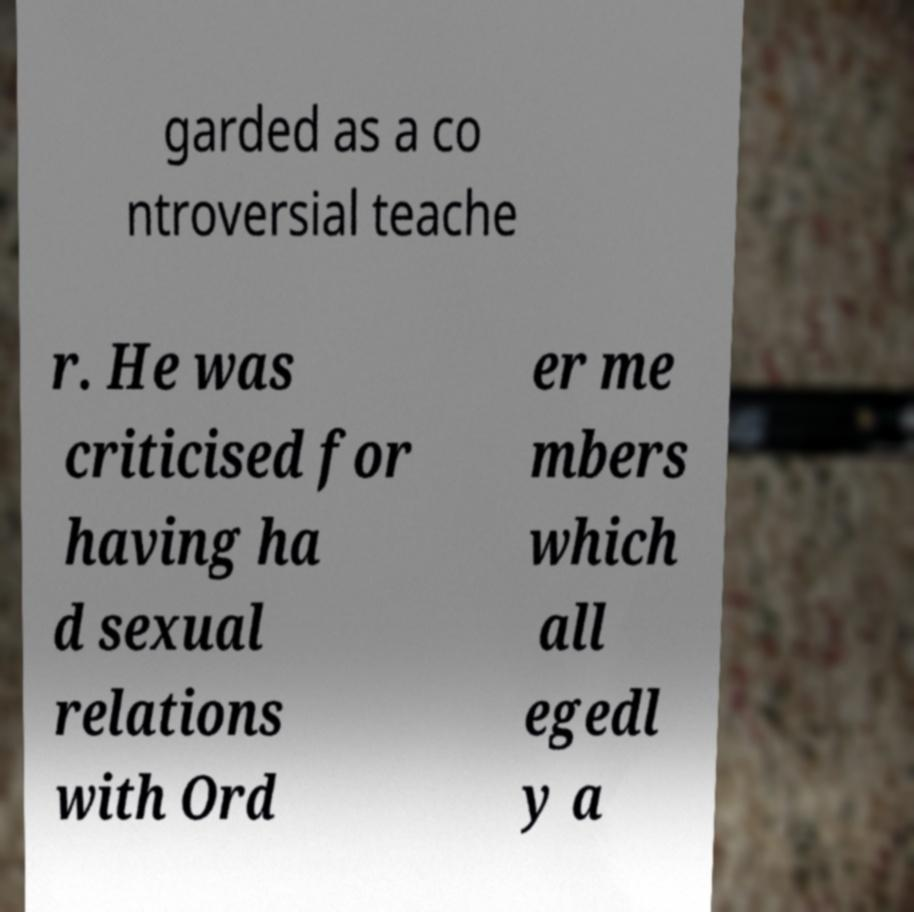What messages or text are displayed in this image? I need them in a readable, typed format. garded as a co ntroversial teache r. He was criticised for having ha d sexual relations with Ord er me mbers which all egedl y a 